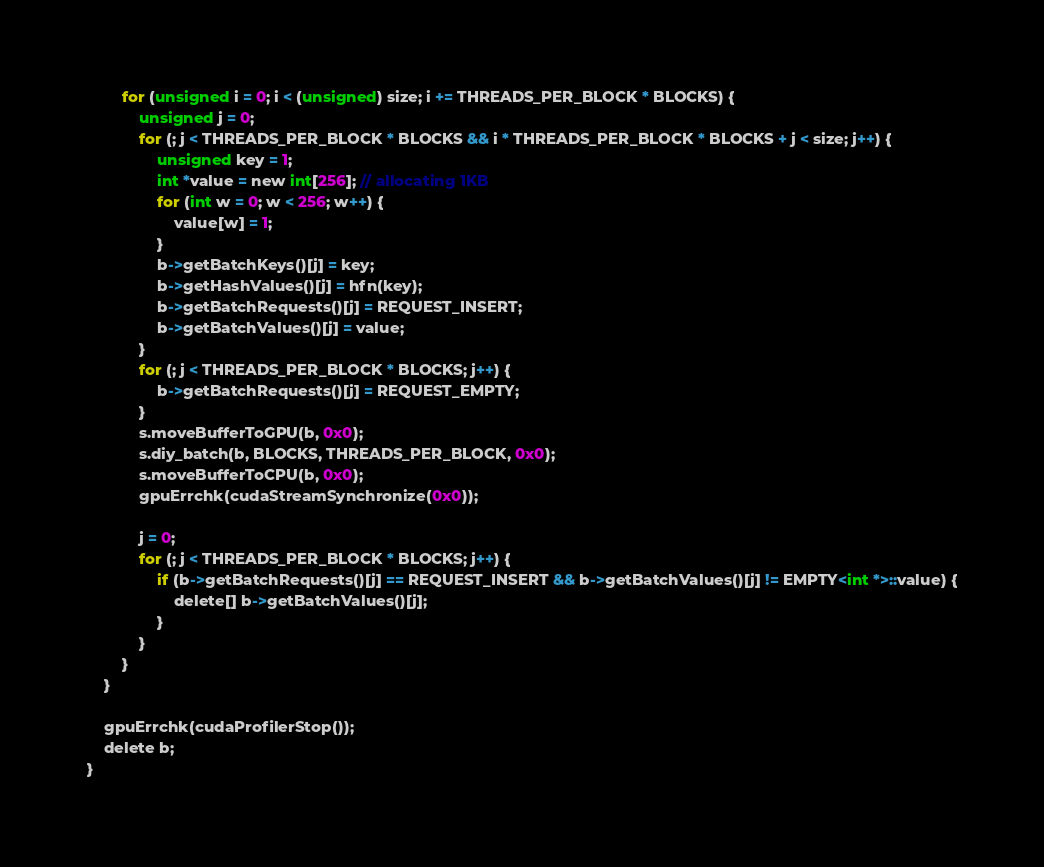Convert code to text. <code><loc_0><loc_0><loc_500><loc_500><_Cuda_>        for (unsigned i = 0; i < (unsigned) size; i += THREADS_PER_BLOCK * BLOCKS) {
            unsigned j = 0;
            for (; j < THREADS_PER_BLOCK * BLOCKS && i * THREADS_PER_BLOCK * BLOCKS + j < size; j++) {
                unsigned key = 1;
                int *value = new int[256]; // allocating 1KB
                for (int w = 0; w < 256; w++) {
                    value[w] = 1;
                }
                b->getBatchKeys()[j] = key;
                b->getHashValues()[j] = hfn(key);
                b->getBatchRequests()[j] = REQUEST_INSERT;
                b->getBatchValues()[j] = value;
            }
            for (; j < THREADS_PER_BLOCK * BLOCKS; j++) {
                b->getBatchRequests()[j] = REQUEST_EMPTY;
            }
            s.moveBufferToGPU(b, 0x0);
            s.diy_batch(b, BLOCKS, THREADS_PER_BLOCK, 0x0);
            s.moveBufferToCPU(b, 0x0);
            gpuErrchk(cudaStreamSynchronize(0x0));

            j = 0;
            for (; j < THREADS_PER_BLOCK * BLOCKS; j++) {
                if (b->getBatchRequests()[j] == REQUEST_INSERT && b->getBatchValues()[j] != EMPTY<int *>::value) {
                    delete[] b->getBatchValues()[j];
                }
            }
        }
    }

    gpuErrchk(cudaProfilerStop());
    delete b;
}</code> 